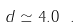Convert formula to latex. <formula><loc_0><loc_0><loc_500><loc_500>d \simeq 4 . 0 \ .</formula> 